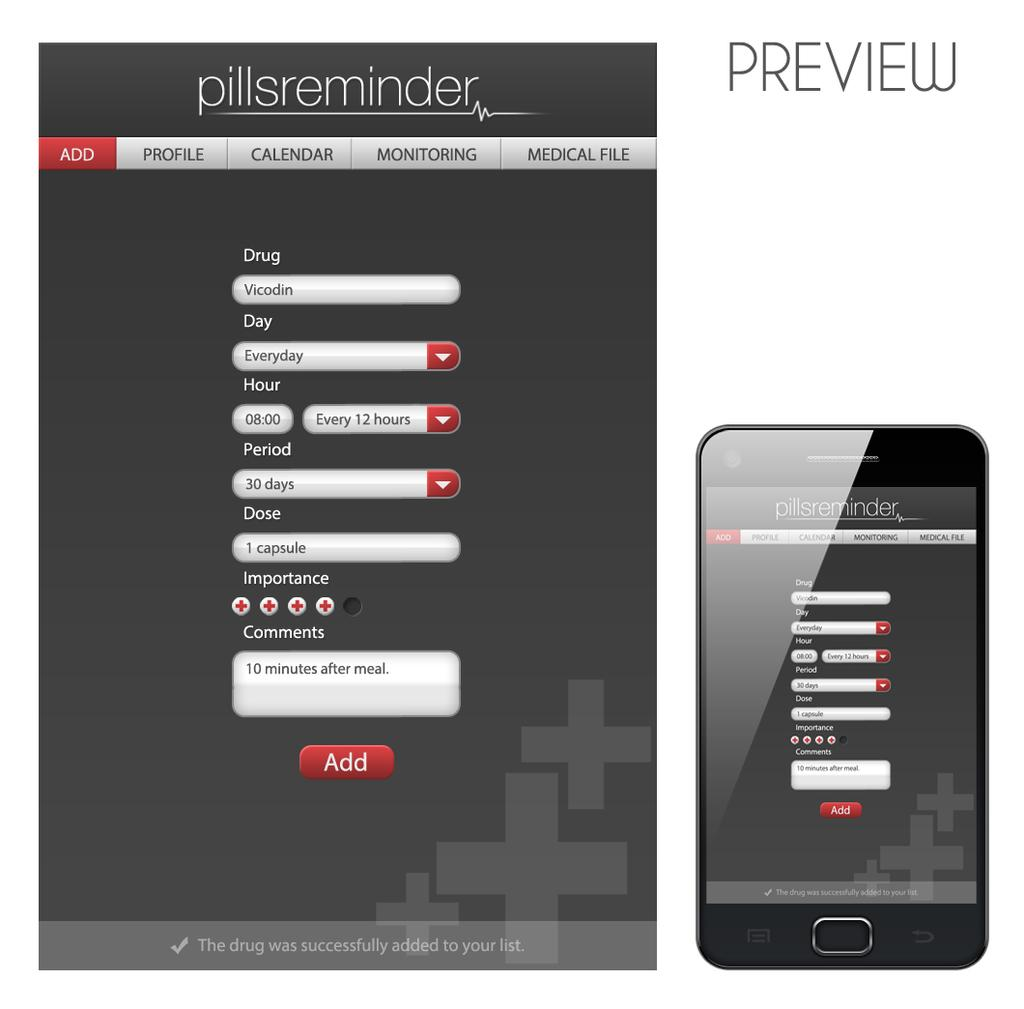<image>
Create a compact narrative representing the image presented. An ad with a phone next to a tablet and both have Pillsreminder on the screens. 